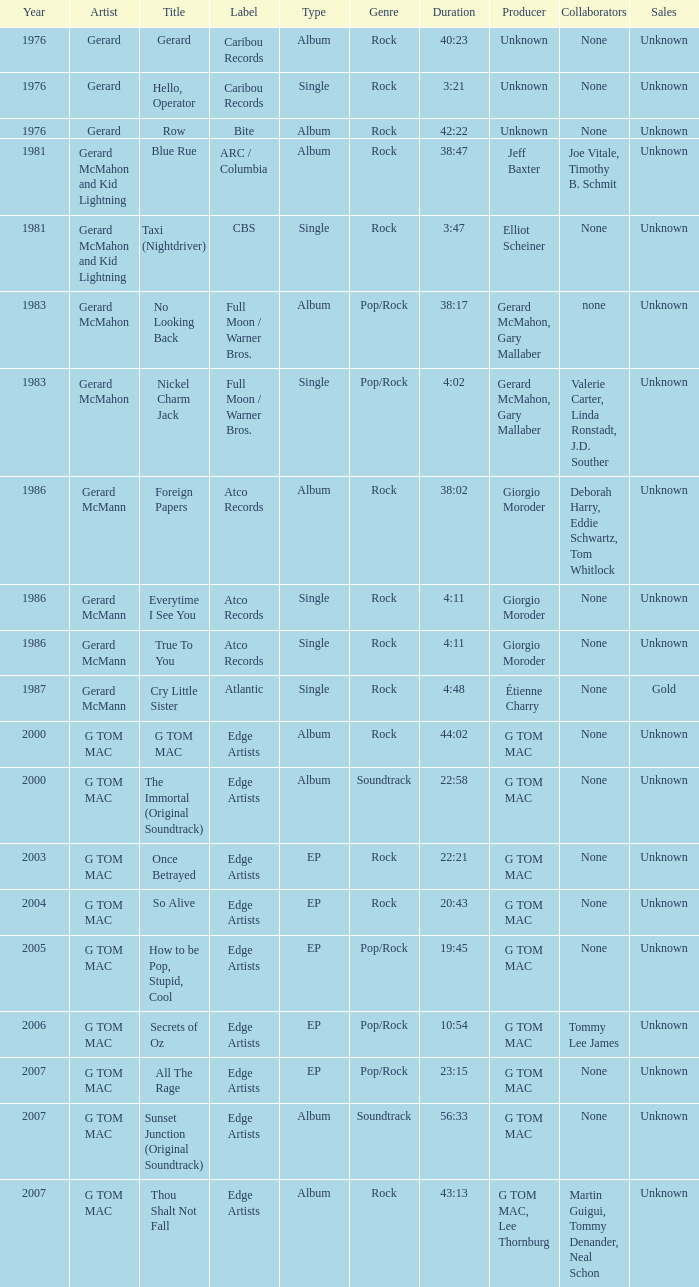Which Title has a Type of ep and a Year larger than 2003? So Alive, How to be Pop, Stupid, Cool, Secrets of Oz, All The Rage. 